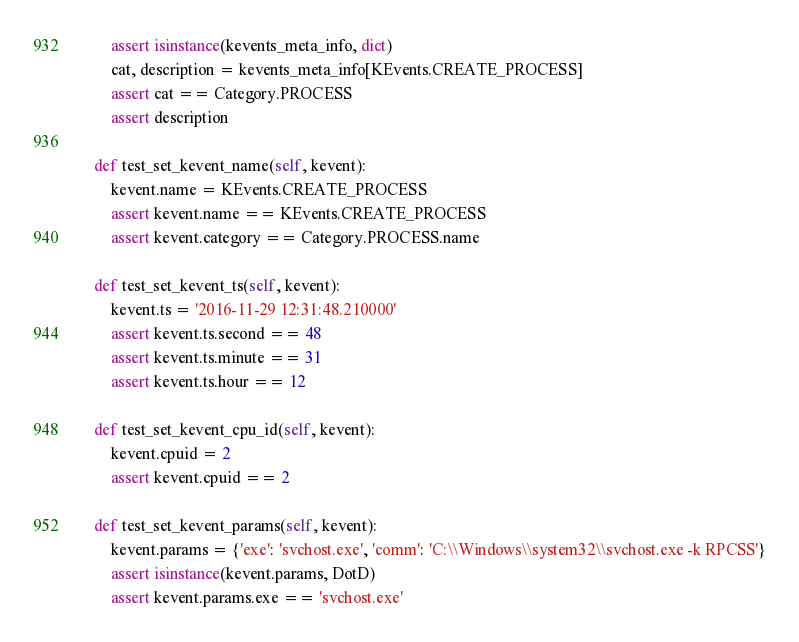Convert code to text. <code><loc_0><loc_0><loc_500><loc_500><_Python_>        assert isinstance(kevents_meta_info, dict)
        cat, description = kevents_meta_info[KEvents.CREATE_PROCESS]
        assert cat == Category.PROCESS
        assert description

    def test_set_kevent_name(self, kevent):
        kevent.name = KEvents.CREATE_PROCESS
        assert kevent.name == KEvents.CREATE_PROCESS
        assert kevent.category == Category.PROCESS.name

    def test_set_kevent_ts(self, kevent):
        kevent.ts = '2016-11-29 12:31:48.210000'
        assert kevent.ts.second == 48
        assert kevent.ts.minute == 31
        assert kevent.ts.hour == 12

    def test_set_kevent_cpu_id(self, kevent):
        kevent.cpuid = 2
        assert kevent.cpuid == 2

    def test_set_kevent_params(self, kevent):
        kevent.params = {'exe': 'svchost.exe', 'comm': 'C:\\Windows\\system32\\svchost.exe -k RPCSS'}
        assert isinstance(kevent.params, DotD)
        assert kevent.params.exe == 'svchost.exe'

</code> 